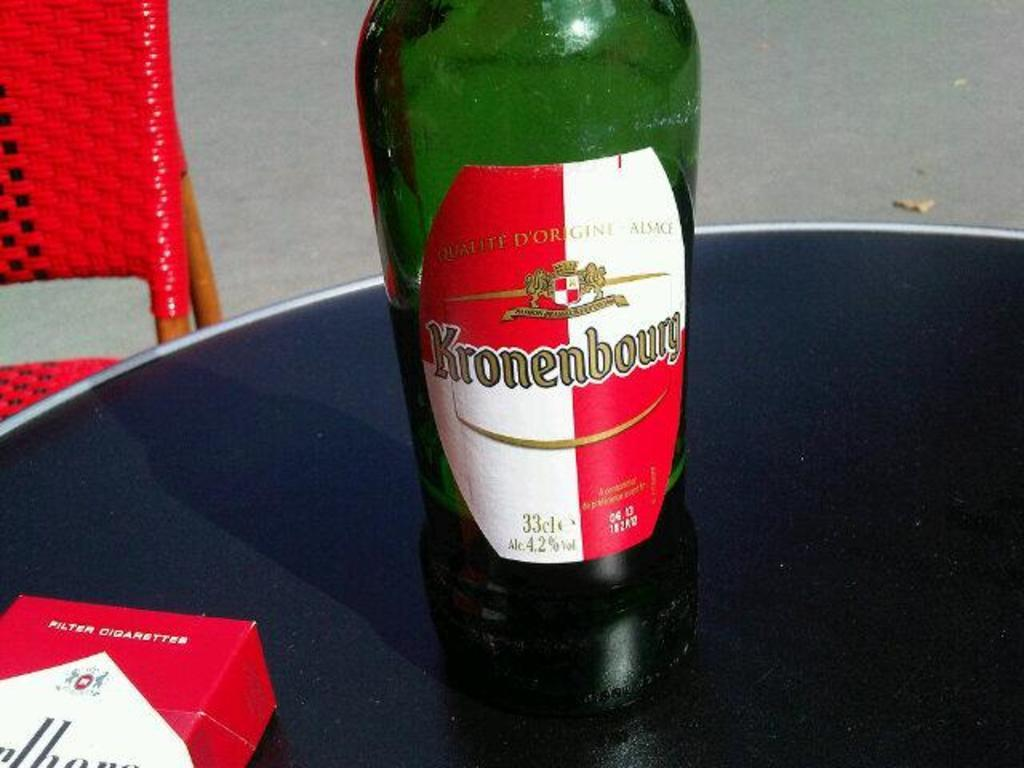<image>
Provide a brief description of the given image. A green bottled with a red and white label for Kronenbourg next to a pack of Marlboros cigarettes. 